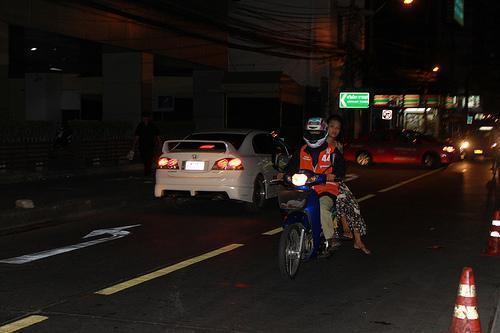How many white cars are there?
Give a very brief answer. 1. 